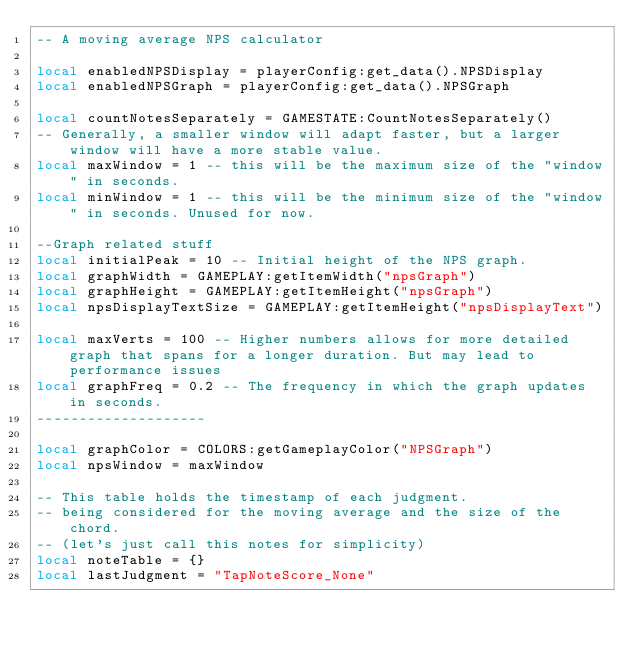<code> <loc_0><loc_0><loc_500><loc_500><_Lua_>-- A moving average NPS calculator

local enabledNPSDisplay = playerConfig:get_data().NPSDisplay
local enabledNPSGraph = playerConfig:get_data().NPSGraph

local countNotesSeparately = GAMESTATE:CountNotesSeparately()
-- Generally, a smaller window will adapt faster, but a larger window will have a more stable value.
local maxWindow = 1 -- this will be the maximum size of the "window" in seconds.
local minWindow = 1 -- this will be the minimum size of the "window" in seconds. Unused for now.

--Graph related stuff
local initialPeak = 10 -- Initial height of the NPS graph.
local graphWidth = GAMEPLAY:getItemWidth("npsGraph")
local graphHeight = GAMEPLAY:getItemHeight("npsGraph")
local npsDisplayTextSize = GAMEPLAY:getItemHeight("npsDisplayText")

local maxVerts = 100 -- Higher numbers allows for more detailed graph that spans for a longer duration. But may lead to performance issues
local graphFreq = 0.2 -- The frequency in which the graph updates in seconds.
--------------------

local graphColor = COLORS:getGameplayColor("NPSGraph")
local npsWindow = maxWindow

-- This table holds the timestamp of each judgment.
-- being considered for the moving average and the size of the chord.
-- (let's just call this notes for simplicity)
local noteTable = {}
local lastJudgment = "TapNoteScore_None"
</code> 